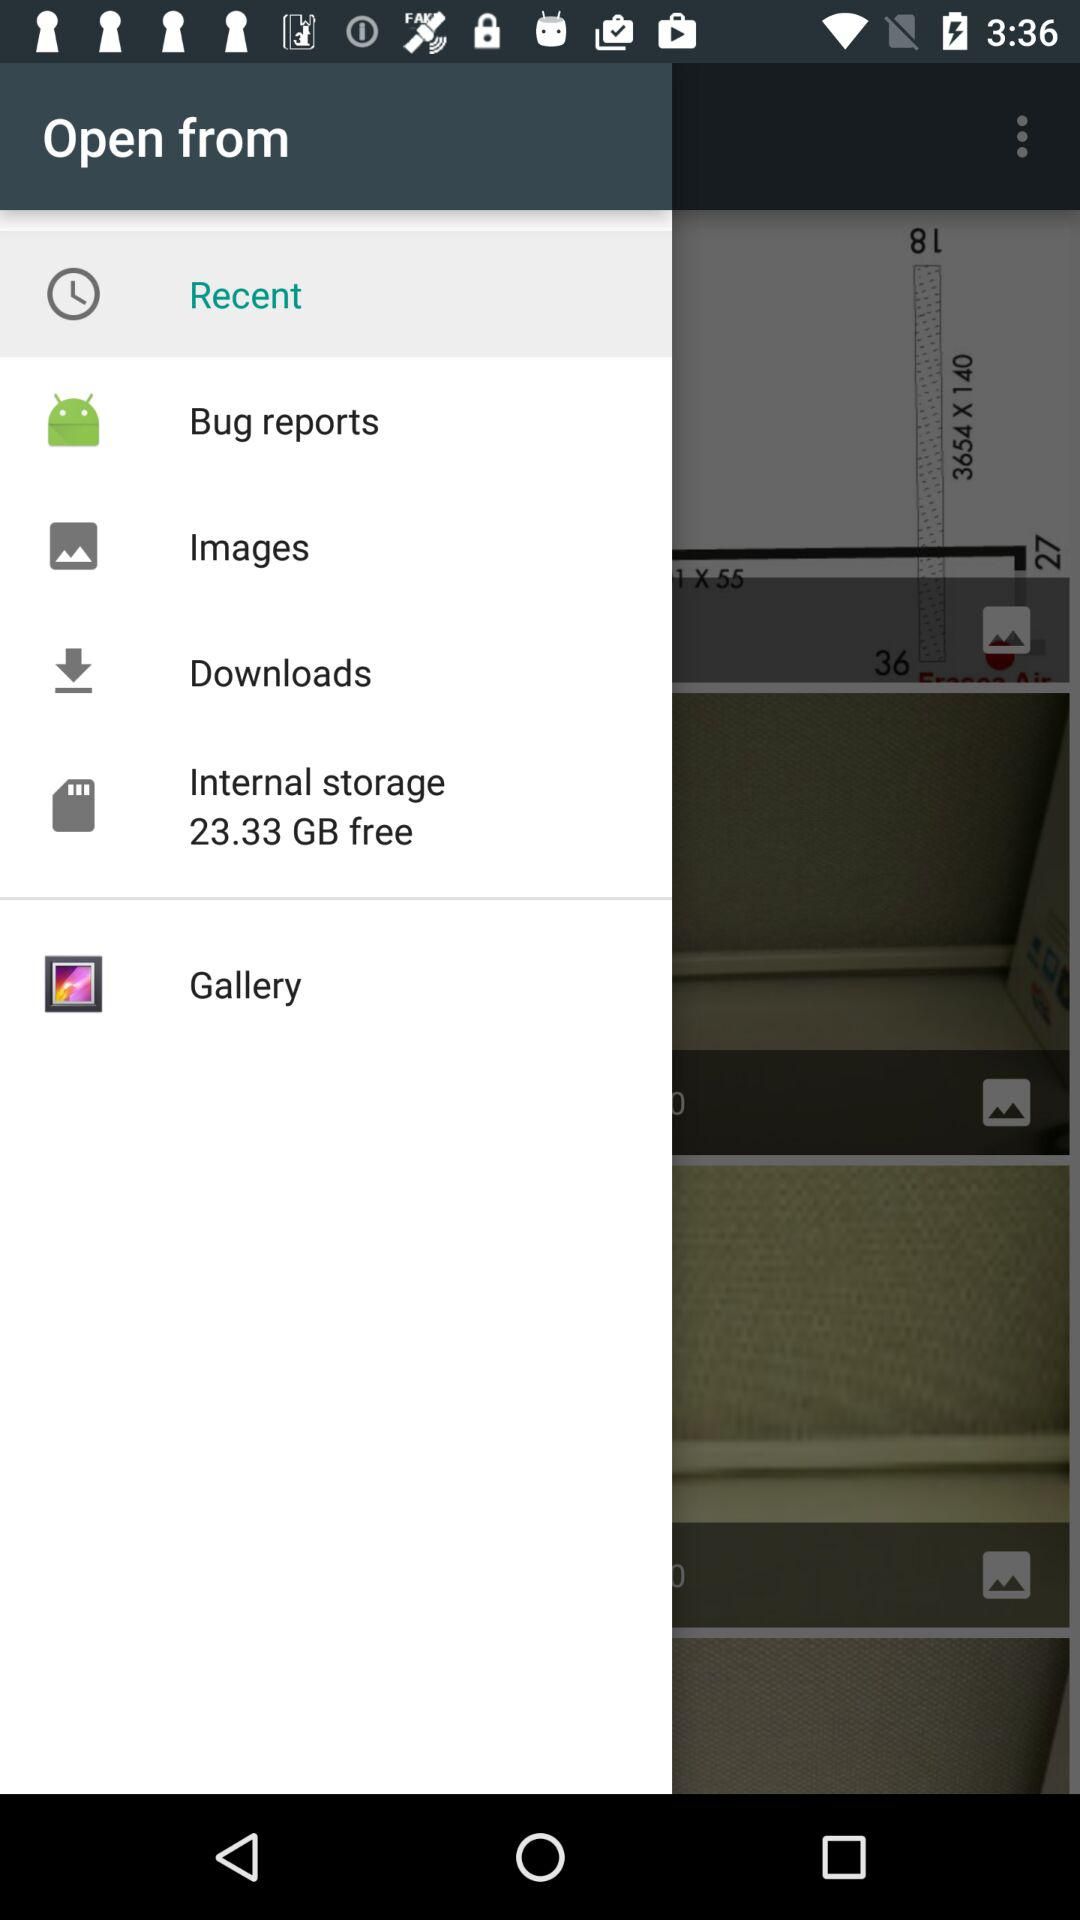What amount of internal storage is free in terms of GB? Internal storage of 23.33 GB is free. 